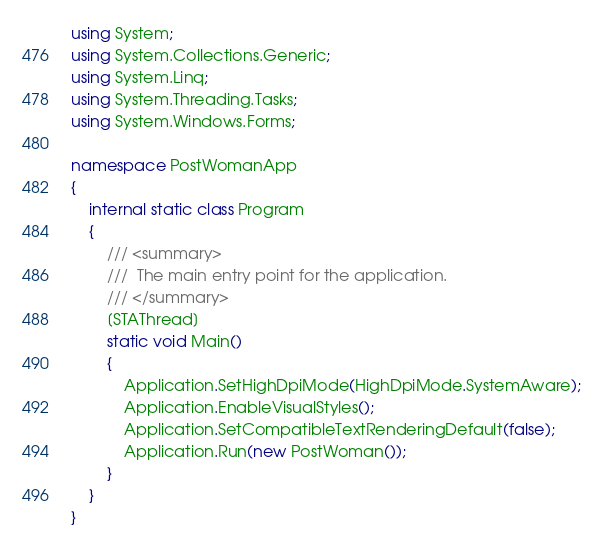Convert code to text. <code><loc_0><loc_0><loc_500><loc_500><_C#_>using System;
using System.Collections.Generic;
using System.Linq;
using System.Threading.Tasks;
using System.Windows.Forms;

namespace PostWomanApp
{
    internal static class Program
    {
        /// <summary>
        ///  The main entry point for the application.
        /// </summary>
        [STAThread]
        static void Main()
        {
            Application.SetHighDpiMode(HighDpiMode.SystemAware);
            Application.EnableVisualStyles();
            Application.SetCompatibleTextRenderingDefault(false);
            Application.Run(new PostWoman());
        }
    }
}
</code> 